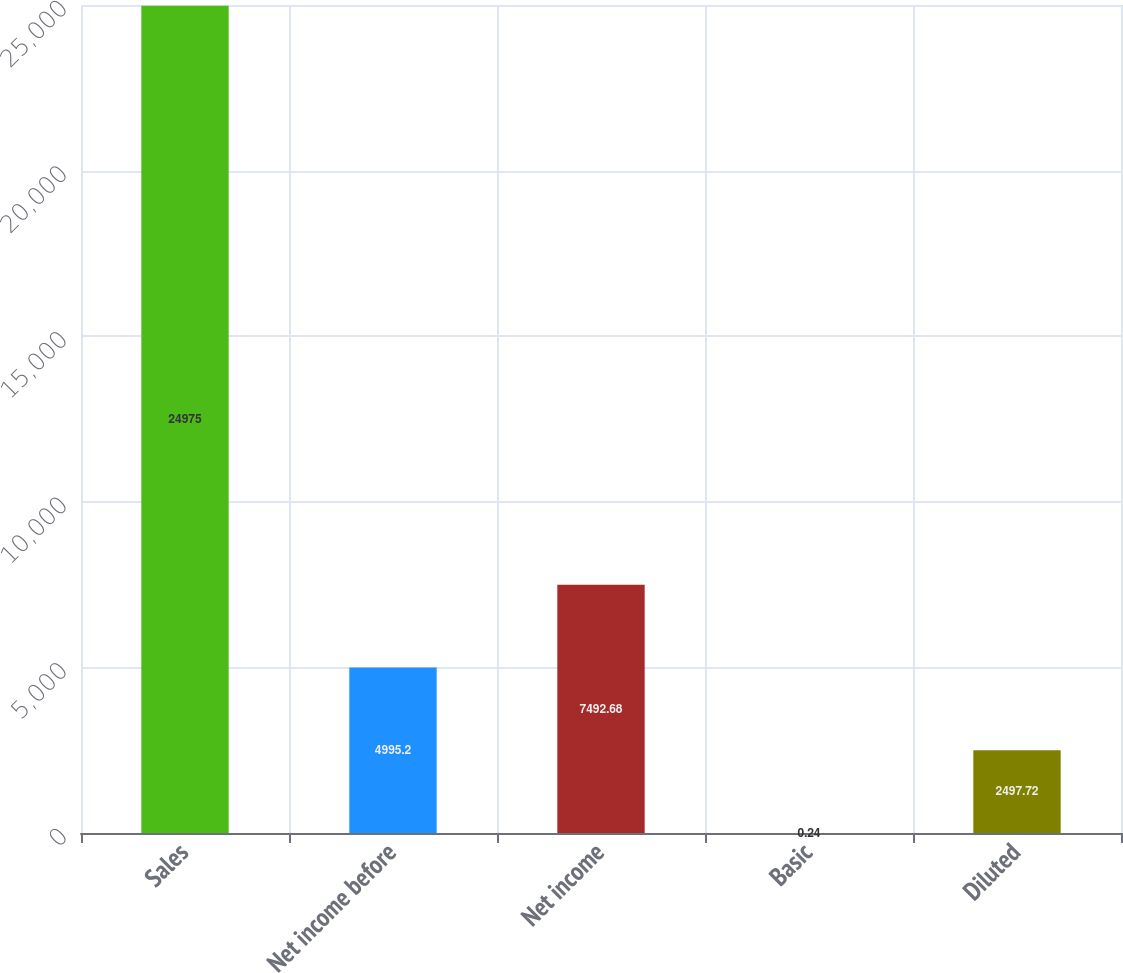<chart> <loc_0><loc_0><loc_500><loc_500><bar_chart><fcel>Sales<fcel>Net income before<fcel>Net income<fcel>Basic<fcel>Diluted<nl><fcel>24975<fcel>4995.2<fcel>7492.68<fcel>0.24<fcel>2497.72<nl></chart> 